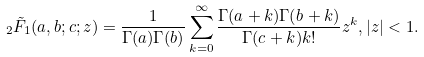Convert formula to latex. <formula><loc_0><loc_0><loc_500><loc_500>_ { 2 } \tilde { F } _ { 1 } ( a , b ; c ; z ) = \frac { 1 } { \Gamma ( a ) \Gamma ( b ) } \sum _ { k = 0 } ^ { \infty } \frac { \Gamma ( a + k ) \Gamma ( b + k ) } { \Gamma ( c + k ) k ! } z ^ { k } , | z | < 1 .</formula> 